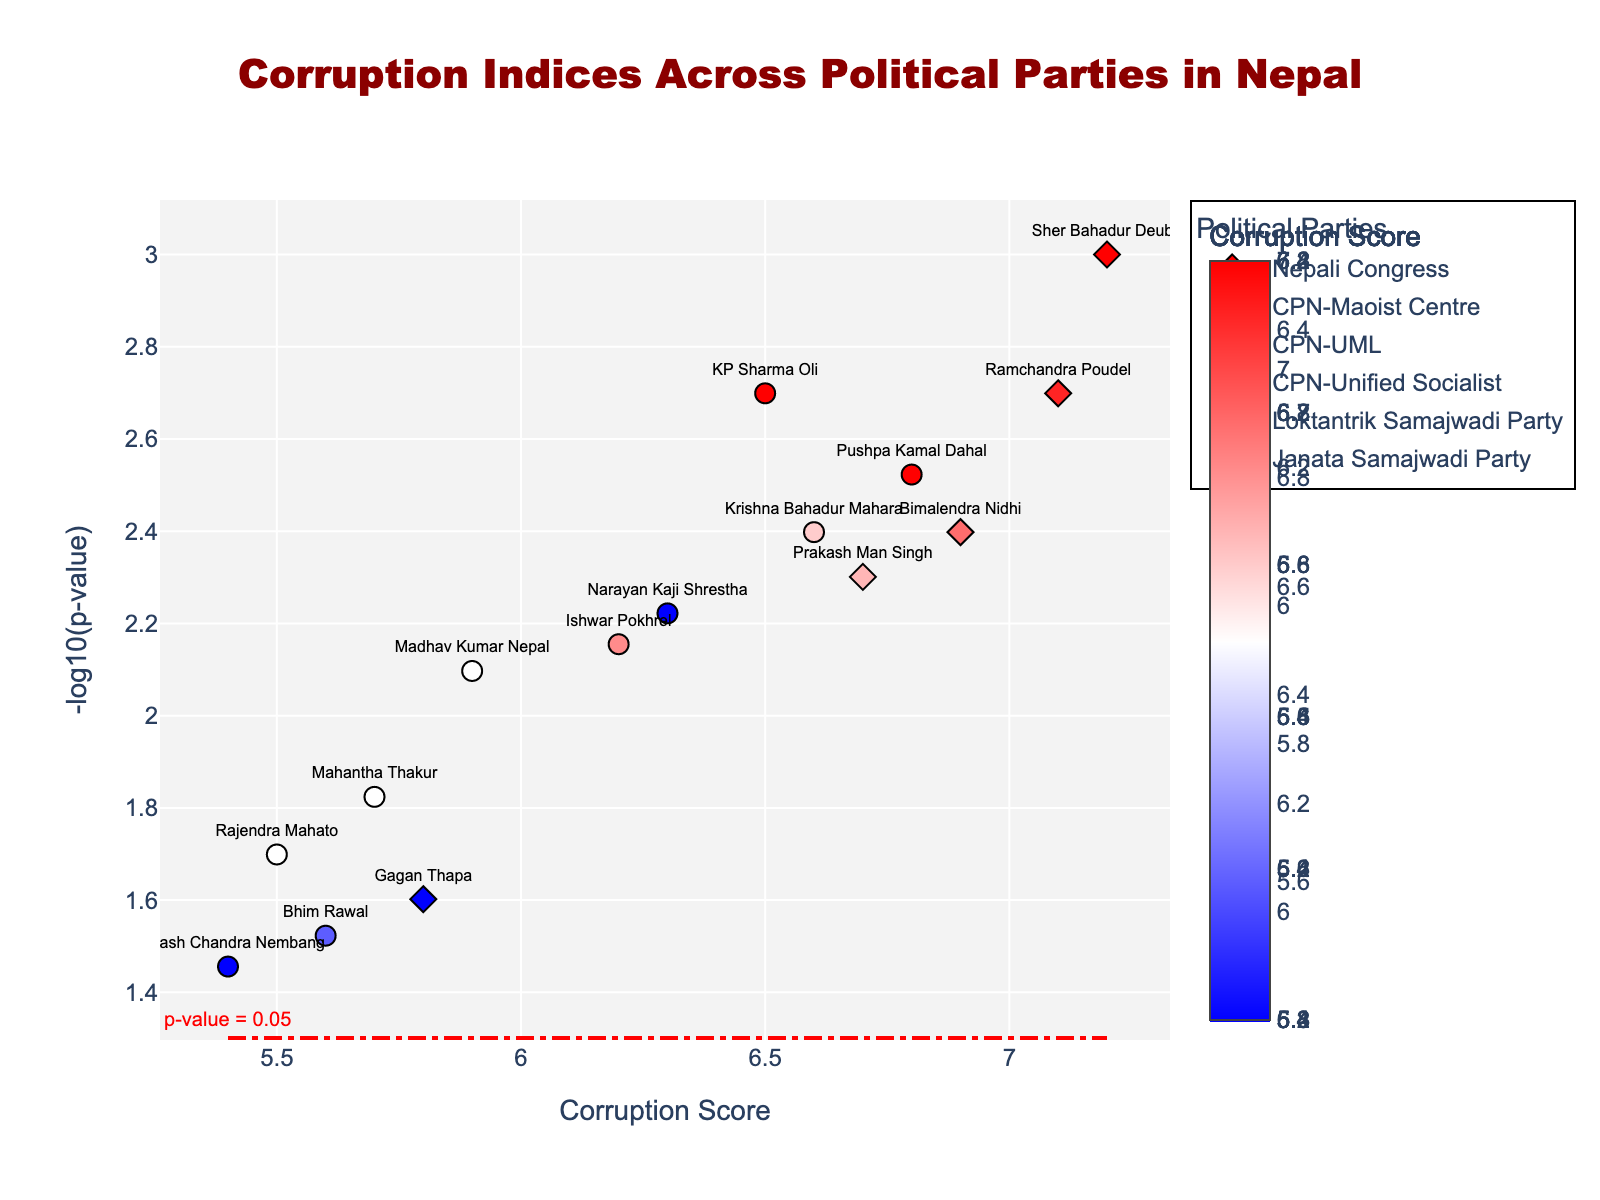What is the title of the figure? The title is usually prominently displayed at the top of the figure. In this case, it reads "Corruption Indices Across Political Parties in Nepal".
Answer: Corruption Indices Across Political Parties in Nepal What's the corruption score of Sher Bahadur Deuba? Sher Bahadur Deuba’s corruption score can be found by locating his name in the figure and referencing his position on the x-axis.
Answer: 7.2 Which party has the highest corruption score in this plot? By checking the plot, the highest corruption scores are held by Nepali Congress politicians (Sher Bahadur Deuba with a score of 7.2, and Ramchandra Poudel with a score of 7.1).
Answer: Nepali Congress What color represents the corruption scores above 6.0? The color scale in the plot shifts from blue to red; corruption scores above 6.0 have a more red-like color.
Answer: Red How many Nepali Congress Party members have a corruption score higher than 6.5? Checking the corruption scores of each Nepali Congress member visible in the plot, Sher Bahadur Deuba (7.2), Ramchandra Poudel (7.1), Bimalendra Nidhi (6.9), and Prakash Man Singh (6.7) have scores higher than 6.5. Total count is 4.
Answer: 4 Which politician has the lowest corruption score among CPN-UML members? Look for the politician with the lowest corruption score among the CPN-UML members by checking their positions on the x-axis: Subash Chandra Nembang has the lowest score of 5.4.
Answer: Subash Chandra Nembang What's the significance of the horizontal line in the plot? The horizontal line corresponds to the -log10 of a p-value threshold (p=0.05), implying significance above this line and irrelevant below.
Answer: p-value = 0.05 Which politician has the highest significance (lowest p-value)? The height of each point indicates significance, with higher y-values representing lower p-values. Sher Bahadur Deuba, at the highest point, has the most significance.
Answer: Sher Bahadur Deuba Compare the corruption scores and significance between Ramchandra Poudel and Prakash Man Singh. Check both politician’s positions on both x and y axes: Ramchandra Poudel has a corruption score of 7.1 and significance (y-axis value) higher than Prakash Man Singh who has a score of 6.7 and slightly lower significance.
Answer: Ramchandra Poudel has higher corruption score and higher significance than Prakash Man Singh What is the average corruption score for Nepali Congress Party members shown in the plot? Calculate the average of the corruption scores for Nepali Congress members: (7.2 + 7.1 + 6.9 + 5.8 + 6.7) / 5. Sum these values (33.7) and divide by 5.
Answer: 6.74 